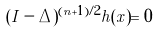<formula> <loc_0><loc_0><loc_500><loc_500>( I - \Delta ) ^ { ( n + 1 ) / 2 } h ( x ) = 0</formula> 